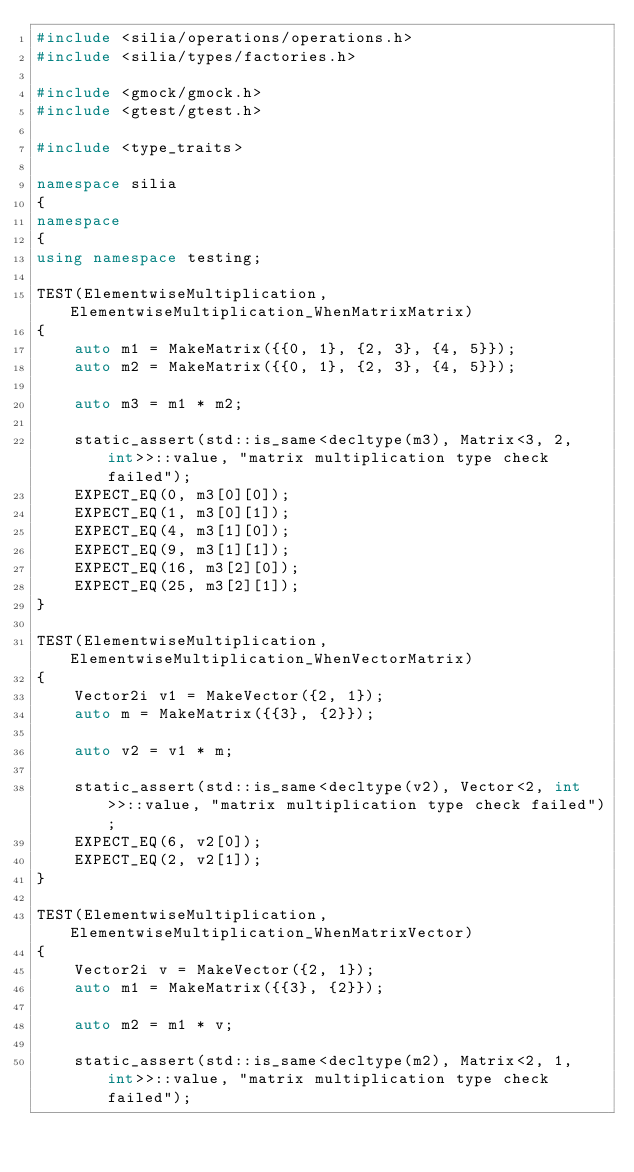Convert code to text. <code><loc_0><loc_0><loc_500><loc_500><_C++_>#include <silia/operations/operations.h>
#include <silia/types/factories.h>

#include <gmock/gmock.h>
#include <gtest/gtest.h>

#include <type_traits>

namespace silia
{
namespace
{
using namespace testing;

TEST(ElementwiseMultiplication, ElementwiseMultiplication_WhenMatrixMatrix)
{
    auto m1 = MakeMatrix({{0, 1}, {2, 3}, {4, 5}});
    auto m2 = MakeMatrix({{0, 1}, {2, 3}, {4, 5}});

    auto m3 = m1 * m2;

    static_assert(std::is_same<decltype(m3), Matrix<3, 2, int>>::value, "matrix multiplication type check failed");
    EXPECT_EQ(0, m3[0][0]);
    EXPECT_EQ(1, m3[0][1]);
    EXPECT_EQ(4, m3[1][0]);
    EXPECT_EQ(9, m3[1][1]);
    EXPECT_EQ(16, m3[2][0]);
    EXPECT_EQ(25, m3[2][1]);
}

TEST(ElementwiseMultiplication, ElementwiseMultiplication_WhenVectorMatrix)
{
    Vector2i v1 = MakeVector({2, 1});
    auto m = MakeMatrix({{3}, {2}});

    auto v2 = v1 * m;

    static_assert(std::is_same<decltype(v2), Vector<2, int>>::value, "matrix multiplication type check failed");
    EXPECT_EQ(6, v2[0]);
    EXPECT_EQ(2, v2[1]);
}

TEST(ElementwiseMultiplication, ElementwiseMultiplication_WhenMatrixVector)
{
    Vector2i v = MakeVector({2, 1});
    auto m1 = MakeMatrix({{3}, {2}});

    auto m2 = m1 * v;

    static_assert(std::is_same<decltype(m2), Matrix<2, 1, int>>::value, "matrix multiplication type check failed");</code> 